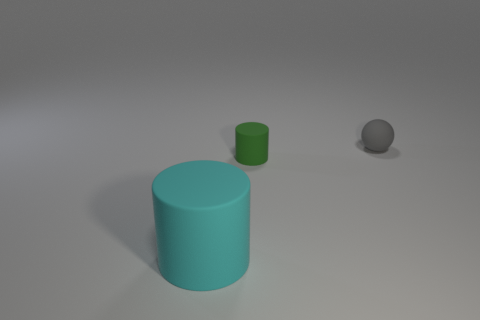What number of cyan things are to the right of the gray thing that is behind the cylinder behind the big cylinder?
Ensure brevity in your answer.  0. Are there any small cyan balls that have the same material as the tiny green thing?
Your response must be concise. No. Is the material of the small green cylinder the same as the gray ball?
Offer a very short reply. Yes. There is a tiny rubber thing in front of the tiny sphere; what number of cylinders are behind it?
Keep it short and to the point. 0. What number of cyan things are either cylinders or small matte cylinders?
Your response must be concise. 1. The small rubber thing that is behind the cylinder on the right side of the large cyan rubber object on the left side of the green thing is what shape?
Ensure brevity in your answer.  Sphere. What is the color of the other rubber thing that is the same size as the green matte object?
Keep it short and to the point. Gray. How many other big cyan matte objects have the same shape as the cyan thing?
Provide a succinct answer. 0. Do the gray sphere and the matte thing to the left of the small green matte cylinder have the same size?
Your answer should be compact. No. The object behind the cylinder that is on the right side of the big matte cylinder is what shape?
Ensure brevity in your answer.  Sphere. 